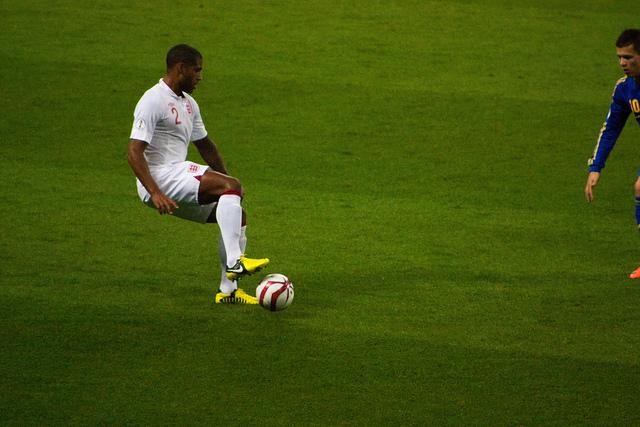What sport is she playing?
Quick response, please. Soccer. What is this girl doing?
Short answer required. Playing soccer. What sport is this person playing?
Be succinct. Soccer. What sport is being played?
Keep it brief. Soccer. What is this person holding?
Be succinct. Nothing. Which game is the man playing?
Short answer required. Soccer. Is he wearing wristbands?
Short answer required. No. Does the lawn need some maintenance?
Concise answer only. No. What is the man doing?
Short answer required. Playing soccer. What sport is being played here?
Keep it brief. Soccer. What number is on the man's shirt?
Answer briefly. 2. What is the man catching?
Be succinct. Soccer ball. What game is being played?
Write a very short answer. Soccer. Which leg does the player in white have lifted?
Concise answer only. Right. Is the man playing soccer?
Give a very brief answer. Yes. What does the man have on his head?
Quick response, please. Hair. 